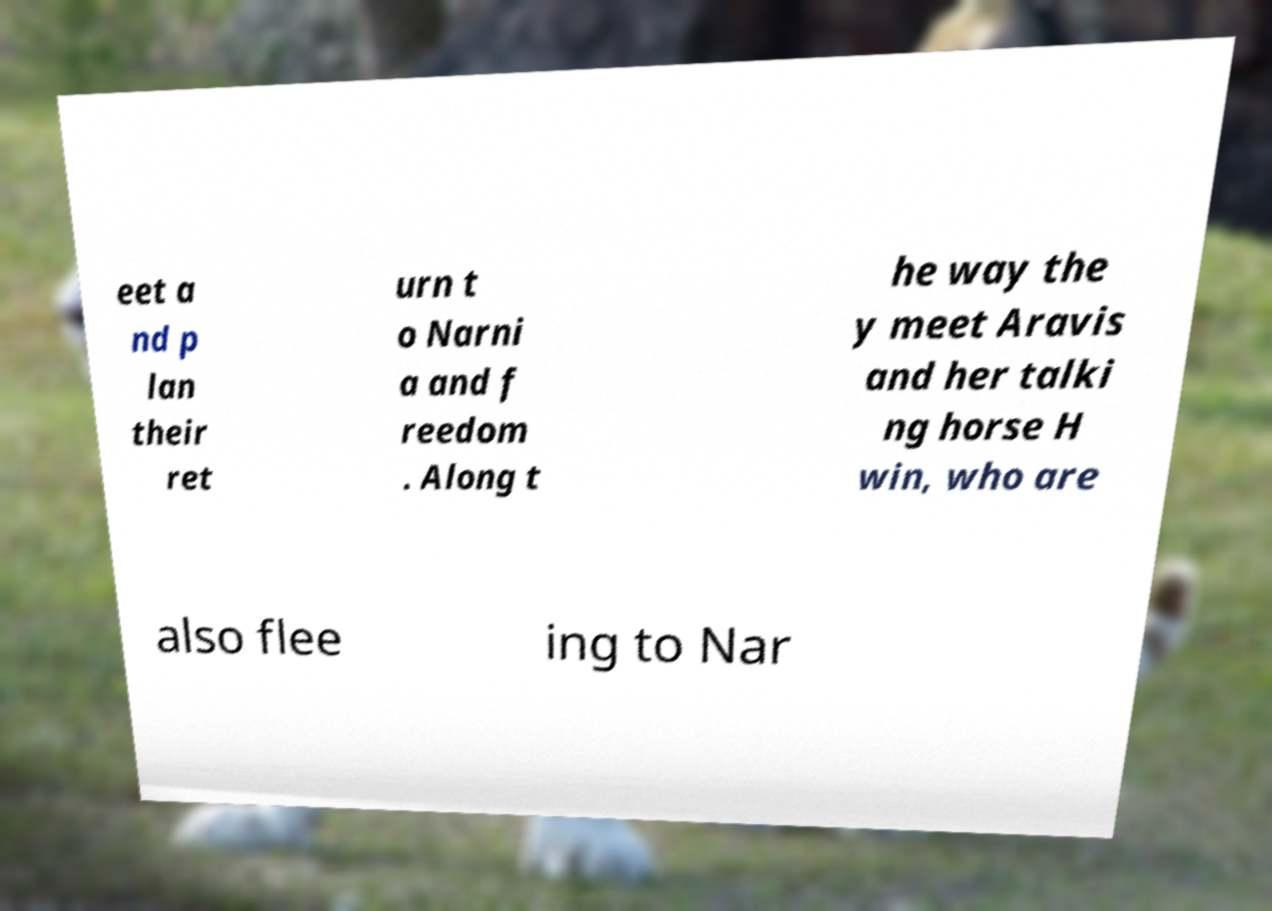Could you extract and type out the text from this image? eet a nd p lan their ret urn t o Narni a and f reedom . Along t he way the y meet Aravis and her talki ng horse H win, who are also flee ing to Nar 